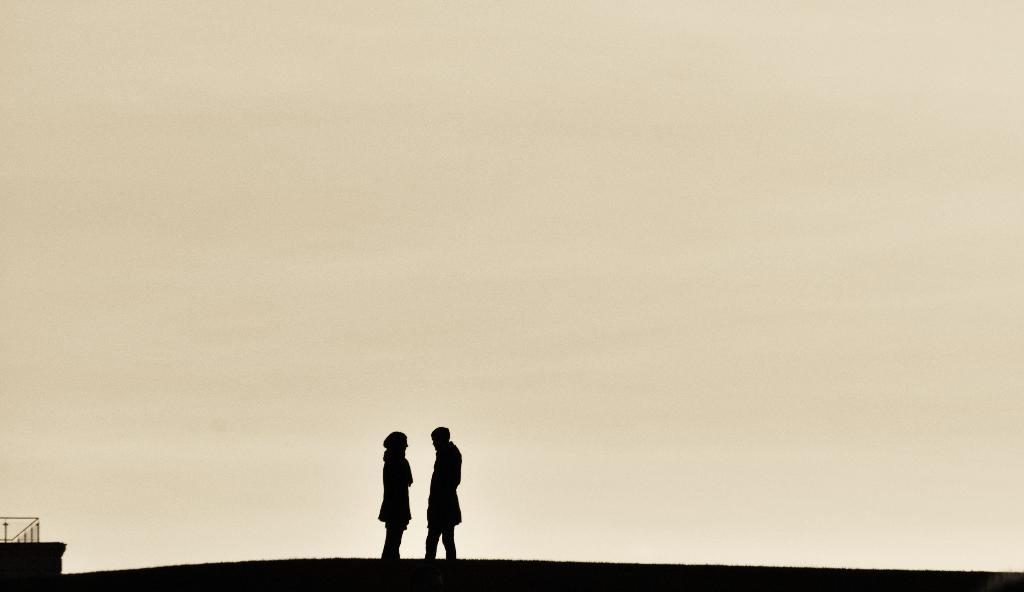What color is the background of the image? The background of the image is yellow. What can be seen in the image besides the background? There are depictions of persons in the image. Where is the scarecrow located in the image? There is no scarecrow present in the image. What type of division is being performed in the image? There is no division being performed in the image; it only contains depictions of persons. 